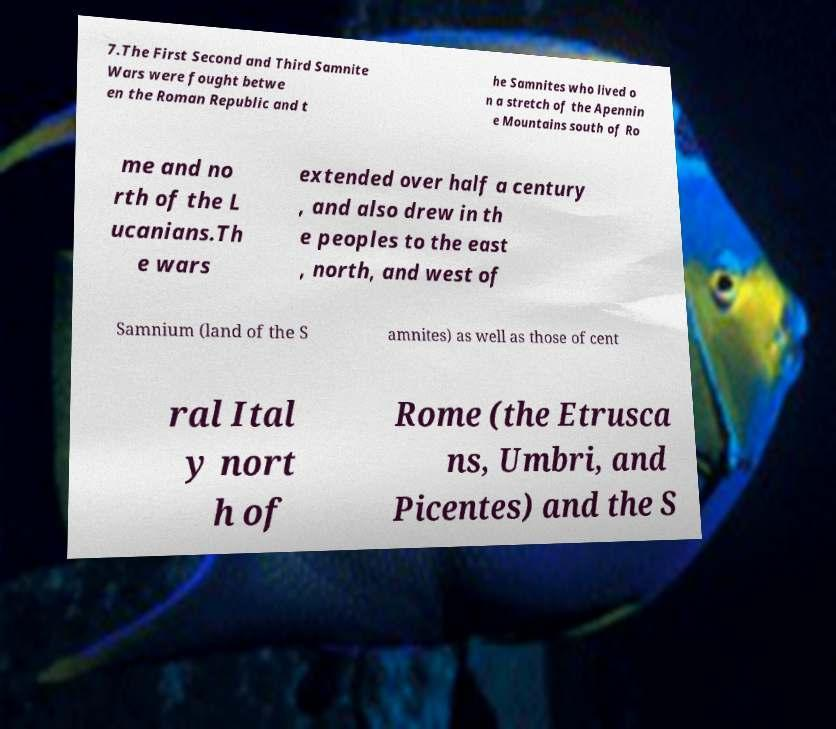Please read and relay the text visible in this image. What does it say? 7.The First Second and Third Samnite Wars were fought betwe en the Roman Republic and t he Samnites who lived o n a stretch of the Apennin e Mountains south of Ro me and no rth of the L ucanians.Th e wars extended over half a century , and also drew in th e peoples to the east , north, and west of Samnium (land of the S amnites) as well as those of cent ral Ital y nort h of Rome (the Etrusca ns, Umbri, and Picentes) and the S 